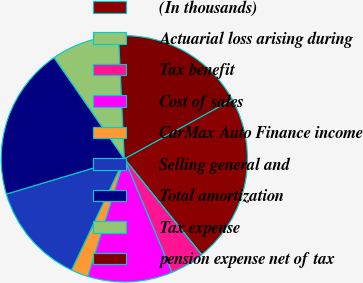<chart> <loc_0><loc_0><loc_500><loc_500><pie_chart><fcel>(In thousands)<fcel>Actuarial loss arising during<fcel>Tax benefit<fcel>Cost of sales<fcel>CarMax Auto Finance income<fcel>Selling general and<fcel>Total amortization<fcel>Tax expense<fcel>pension expense net of tax<nl><fcel>22.19%<fcel>0.03%<fcel>4.46%<fcel>11.11%<fcel>2.25%<fcel>13.33%<fcel>19.98%<fcel>8.9%<fcel>17.76%<nl></chart> 